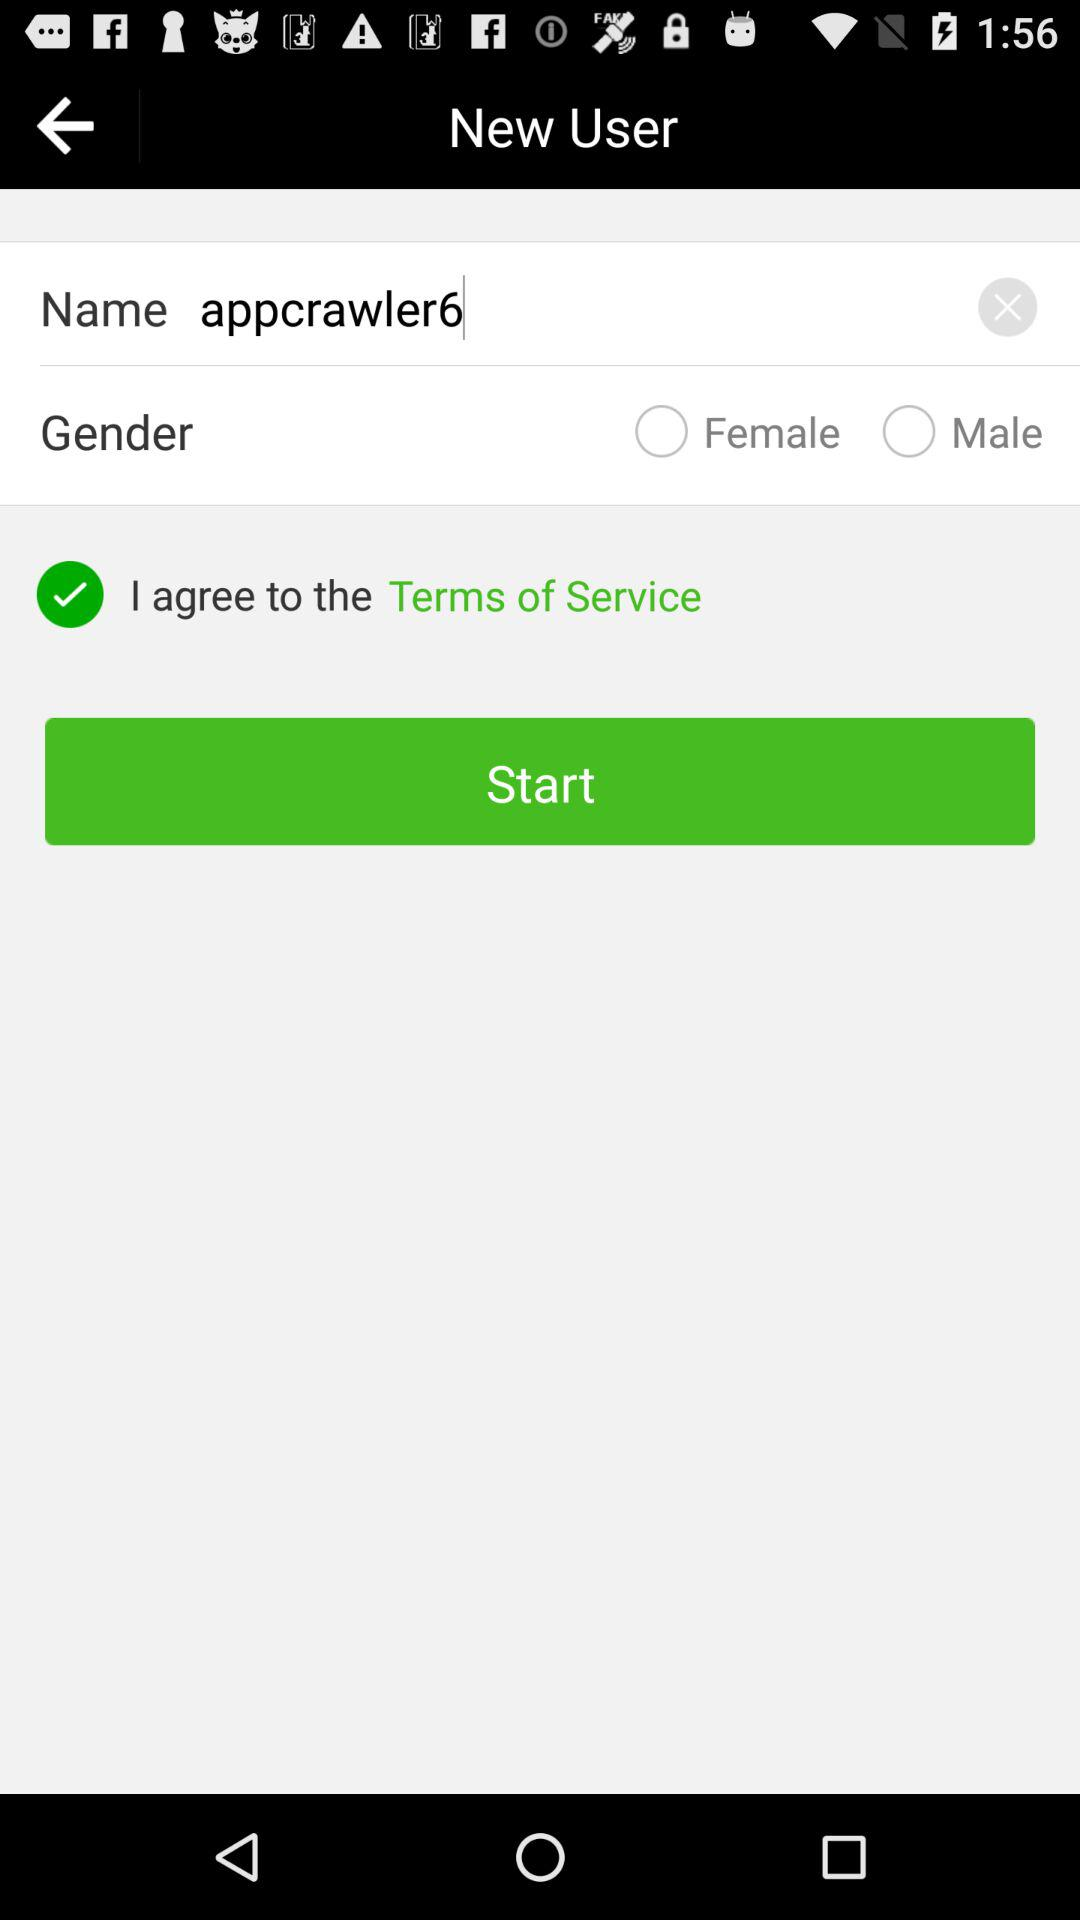Is "Male" selected or not? "Male" is not selected. 